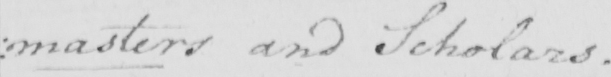Can you read and transcribe this handwriting? masters and Scholars . 